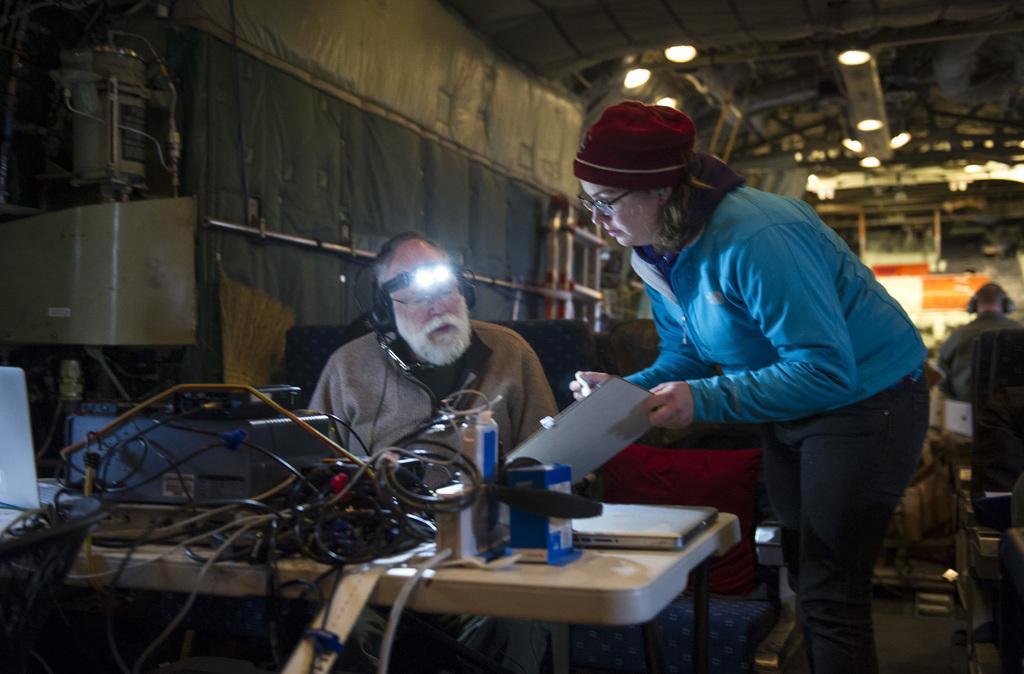Please provide a concise description of this image. In this image I can see three people. In front of two people there is a table. On the table there are some wires and the laptop. In the back there there are some lights. 